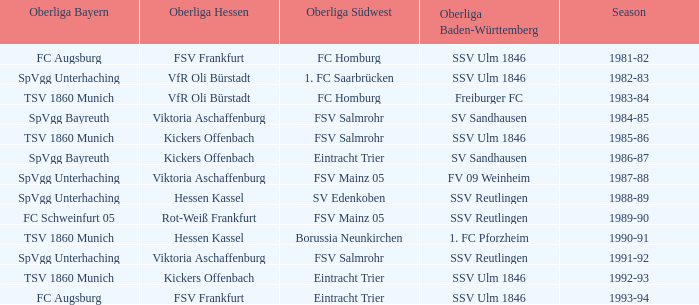Which oberliga bayern features a 1981-82 season? FC Augsburg. Give me the full table as a dictionary. {'header': ['Oberliga Bayern', 'Oberliga Hessen', 'Oberliga Südwest', 'Oberliga Baden-Württemberg', 'Season'], 'rows': [['FC Augsburg', 'FSV Frankfurt', 'FC Homburg', 'SSV Ulm 1846', '1981-82'], ['SpVgg Unterhaching', 'VfR Oli Bürstadt', '1. FC Saarbrücken', 'SSV Ulm 1846', '1982-83'], ['TSV 1860 Munich', 'VfR Oli Bürstadt', 'FC Homburg', 'Freiburger FC', '1983-84'], ['SpVgg Bayreuth', 'Viktoria Aschaffenburg', 'FSV Salmrohr', 'SV Sandhausen', '1984-85'], ['TSV 1860 Munich', 'Kickers Offenbach', 'FSV Salmrohr', 'SSV Ulm 1846', '1985-86'], ['SpVgg Bayreuth', 'Kickers Offenbach', 'Eintracht Trier', 'SV Sandhausen', '1986-87'], ['SpVgg Unterhaching', 'Viktoria Aschaffenburg', 'FSV Mainz 05', 'FV 09 Weinheim', '1987-88'], ['SpVgg Unterhaching', 'Hessen Kassel', 'SV Edenkoben', 'SSV Reutlingen', '1988-89'], ['FC Schweinfurt 05', 'Rot-Weiß Frankfurt', 'FSV Mainz 05', 'SSV Reutlingen', '1989-90'], ['TSV 1860 Munich', 'Hessen Kassel', 'Borussia Neunkirchen', '1. FC Pforzheim', '1990-91'], ['SpVgg Unterhaching', 'Viktoria Aschaffenburg', 'FSV Salmrohr', 'SSV Reutlingen', '1991-92'], ['TSV 1860 Munich', 'Kickers Offenbach', 'Eintracht Trier', 'SSV Ulm 1846', '1992-93'], ['FC Augsburg', 'FSV Frankfurt', 'Eintracht Trier', 'SSV Ulm 1846', '1993-94']]} 